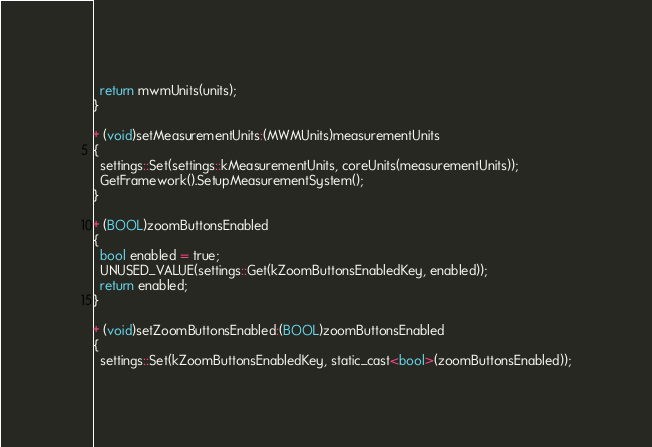<code> <loc_0><loc_0><loc_500><loc_500><_ObjectiveC_>  return mwmUnits(units);
}

+ (void)setMeasurementUnits:(MWMUnits)measurementUnits
{
  settings::Set(settings::kMeasurementUnits, coreUnits(measurementUnits));
  GetFramework().SetupMeasurementSystem();
}

+ (BOOL)zoomButtonsEnabled
{
  bool enabled = true;
  UNUSED_VALUE(settings::Get(kZoomButtonsEnabledKey, enabled));
  return enabled;
}

+ (void)setZoomButtonsEnabled:(BOOL)zoomButtonsEnabled
{
  settings::Set(kZoomButtonsEnabledKey, static_cast<bool>(zoomButtonsEnabled));</code> 